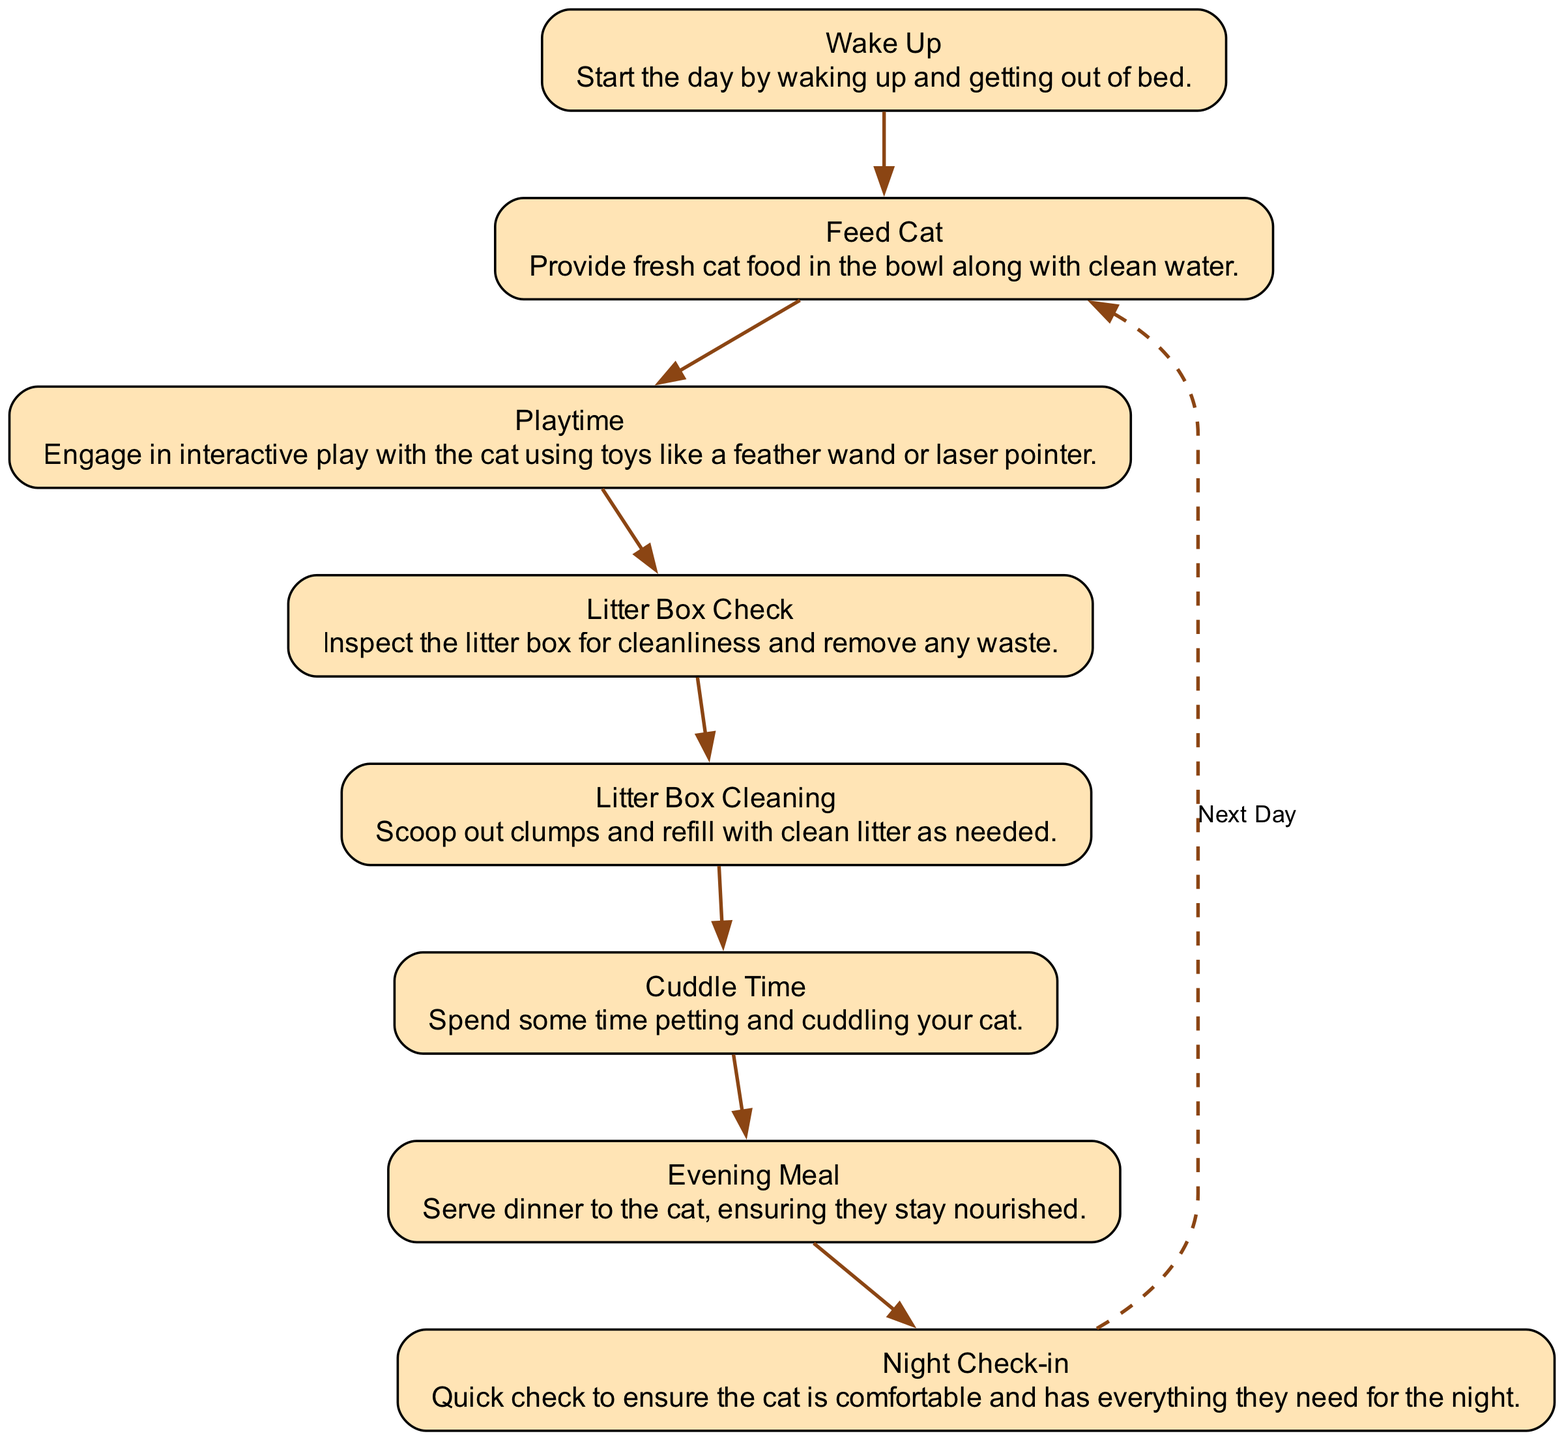What is the first step in the cat care routine? The flow chart starts with the "Wake Up" node, indicating that it is the first action to take in the daily routine.
Answer: Wake Up How many nodes are present in the diagram? The diagram contains eight nodes, each representing a different step of the daily cat care routine, connected in a flow.
Answer: Eight Which node comes directly after "Feed Cat"? After "Feed Cat," the next step indicated in the diagram is "Playtime," showing the sequence of actions in caring for the cat.
Answer: Playtime What action is performed after playtime? The action that follows "Playtime" in the sequence is "Litter Box Check," reflecting the order of tasks as illustrated in the flow chart.
Answer: Litter Box Check What is the final action of the cat care routine before returning to feeding? The last action before the routine cycles back to feeding is "Night Check-in," which ensures the cat's comfort before ending the day.
Answer: Night Check-in How many actions are related to the cat's litter box? There are two actions related to the litter box: "Litter Box Check" and "Litter Box Cleaning," indicating maintenance tasks within the routine.
Answer: Two Is "Cuddle Time" before or after "Evening Meal"? "Cuddle Time" occurs before "Evening Meal" in the sequence, as the flow chart outlines the order of care activities.
Answer: Before What happens after the "Evening Meal"? Following the "Evening Meal," the next action is "Night Check-in," rounding off the day's routine before the next cycle.
Answer: Night Check-in Which step indicates interactive activity with the cat? The node labeled "Playtime" signifies the interactive activity where the caretaker engages the cat using toys.
Answer: Playtime 